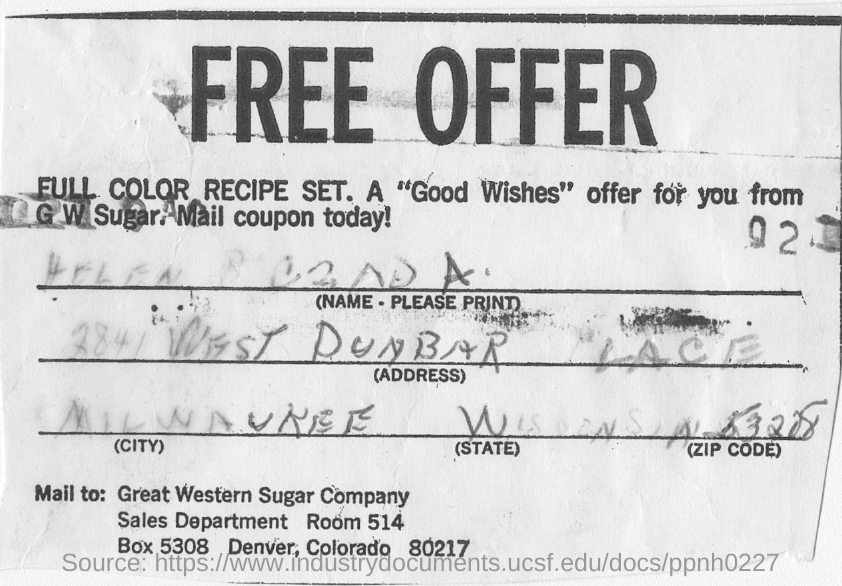Who is the "Good Wishes" offer from?
Give a very brief answer. G W Sugar. Where is the Great Western Sugar Company located?
Make the answer very short. Denver, Colorado. 